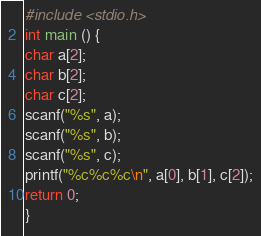<code> <loc_0><loc_0><loc_500><loc_500><_C_>#include <stdio.h>
int main () {
char a[2];
char b[2];
char c[2];
scanf("%s", a);
scanf("%s", b);
scanf("%s", c);
printf("%c%c%c\n", a[0], b[1], c[2]);
return 0;
} </code> 